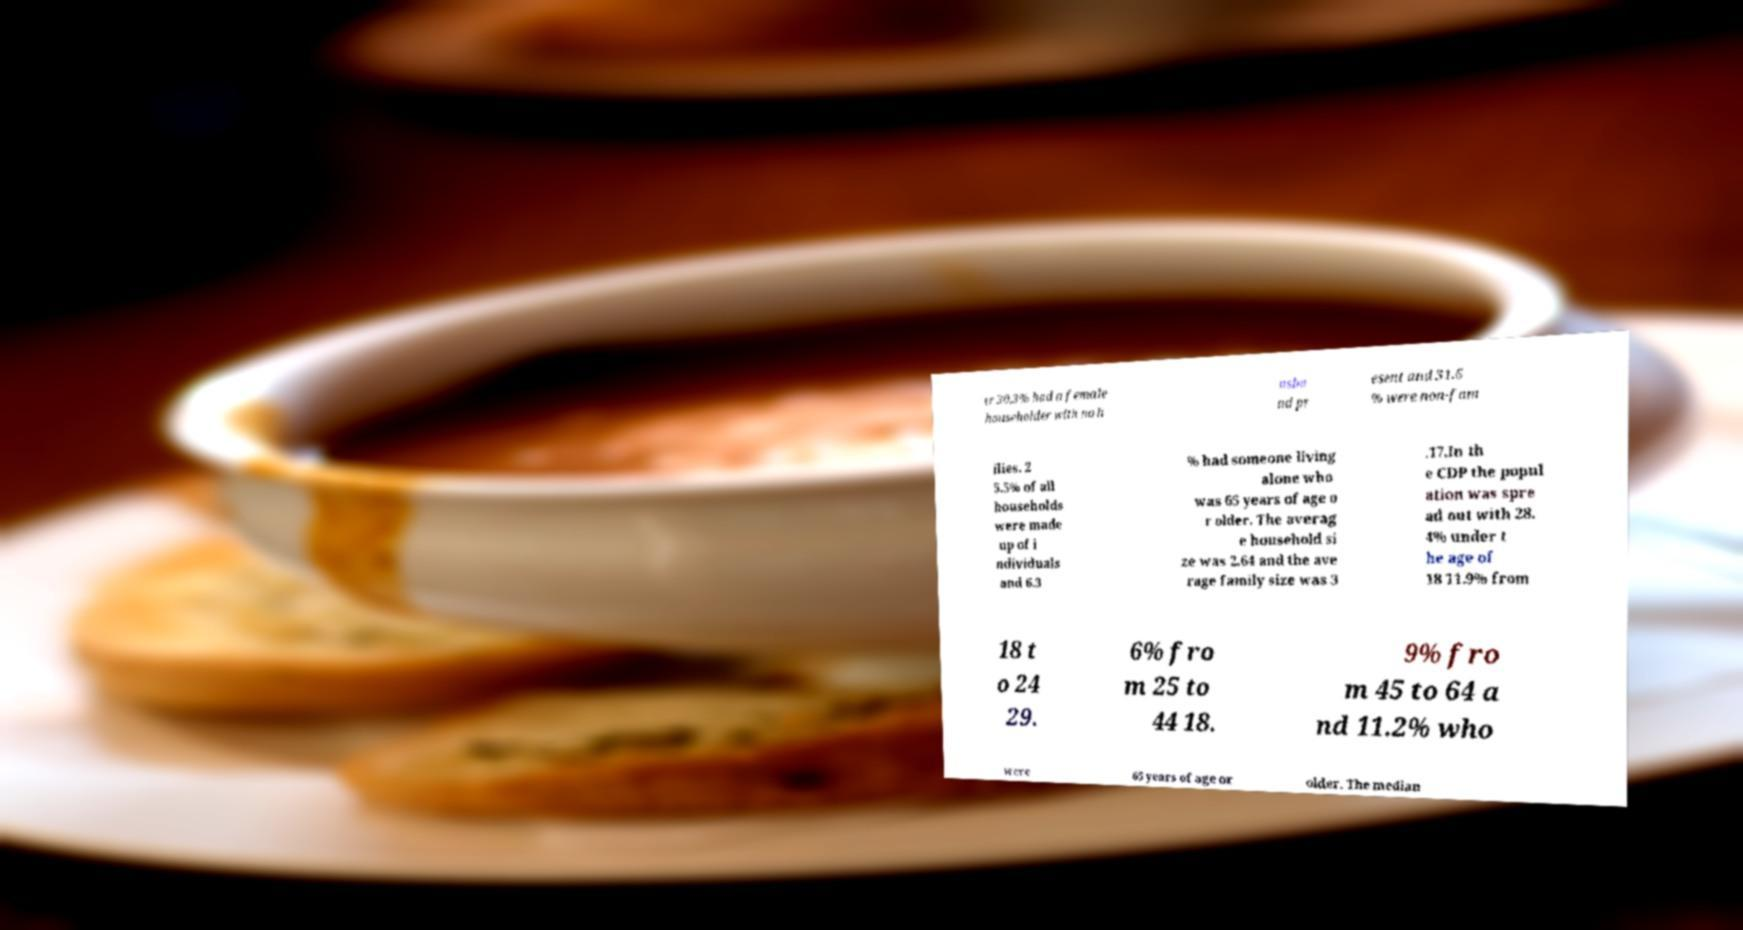What messages or text are displayed in this image? I need them in a readable, typed format. er 30.3% had a female householder with no h usba nd pr esent and 31.6 % were non-fam ilies. 2 5.5% of all households were made up of i ndividuals and 6.3 % had someone living alone who was 65 years of age o r older. The averag e household si ze was 2.64 and the ave rage family size was 3 .17.In th e CDP the popul ation was spre ad out with 28. 4% under t he age of 18 11.9% from 18 t o 24 29. 6% fro m 25 to 44 18. 9% fro m 45 to 64 a nd 11.2% who were 65 years of age or older. The median 